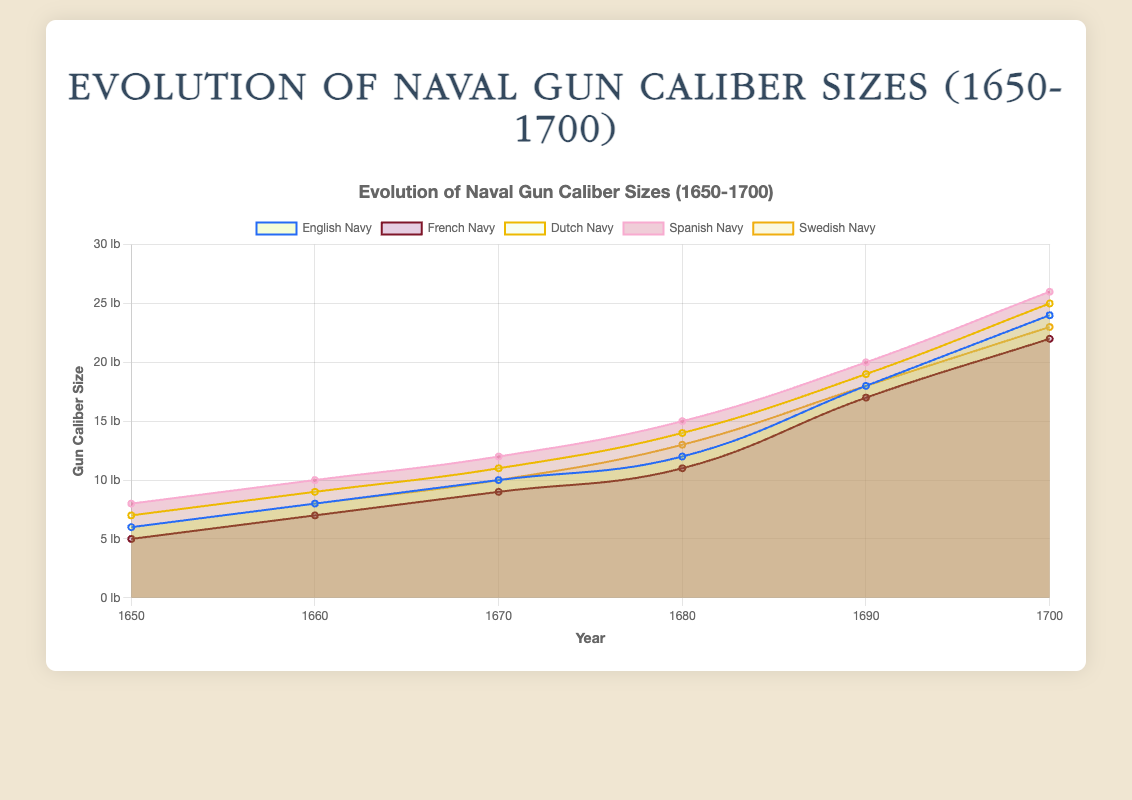What is the title of the chart? The title is displayed at the top of the chart. It reads 'Evolution of Naval Gun Caliber Sizes (1650-1700)'.
Answer: Evolution of Naval Gun Caliber Sizes (1650-1700) Which navy had the largest gun caliber size in 1700? The chart shows the gun caliber sizes for each navy in each year. In 1700, the Spanish Navy has the largest gun caliber size at 26.
Answer: Spanish Navy How did the gun caliber size of the English Navy change from 1650 to 1700? By following the English Navy's line on the chart from 1650 to 1700, we see it increased from 6 to 24.
Answer: Increased from 6 to 24 Which two navies had the closest gun caliber sizes in 1690? Comparing the values in 1690, the English Navy (18) and the Swedish Navy (18) have the same caliber size.
Answer: English Navy and Swedish Navy By how much did the caliber size of the Dutch Navy increase from 1650 to 1700? The caliber size of the Dutch Navy in 1650 was 7 and in 1700 it was 25. The increase is calculated as 25 - 7 = 18.
Answer: 18 What is the caliber size difference between the French Navy and the Spanish Navy in 1680? The caliber size in 1680 for the French Navy is 11 and for the Spanish Navy is 15. The difference is 15 - 11 = 4.
Answer: 4 Which navy showed the most significant increase in gun caliber sizes over the 50-year period? By comparing the caliber sizes in 1650 and 1700 for each navy, the Spanish Navy increased the most from 8 to 26, an increase of 18.
Answer: Spanish Navy What is the average gun caliber size for the Swedish Navy across the given years? The Swedish Navy's sizes are: 6, 8, 10, 13, 18, 23. Their sum is 78, and there are 6 years, so the average is 78 / 6 = 13.
Answer: 13 Which year saw the greatest increase in gun caliber size for the French Navy and what was the increase? The largest increase for the French Navy was from 1680 to 1690, going from 11 to 17. The increase is 17 - 11 = 6.
Answer: 1680 to 1690, increase of 6 In terms of gun caliber size, how do the navies rank in 1700 from largest to smallest? The sizes in 1700 are: Spanish (26), Dutch (25), English (24), Swedish (23), French (22).
Answer: Spanish > Dutch > English > Swedish > French 